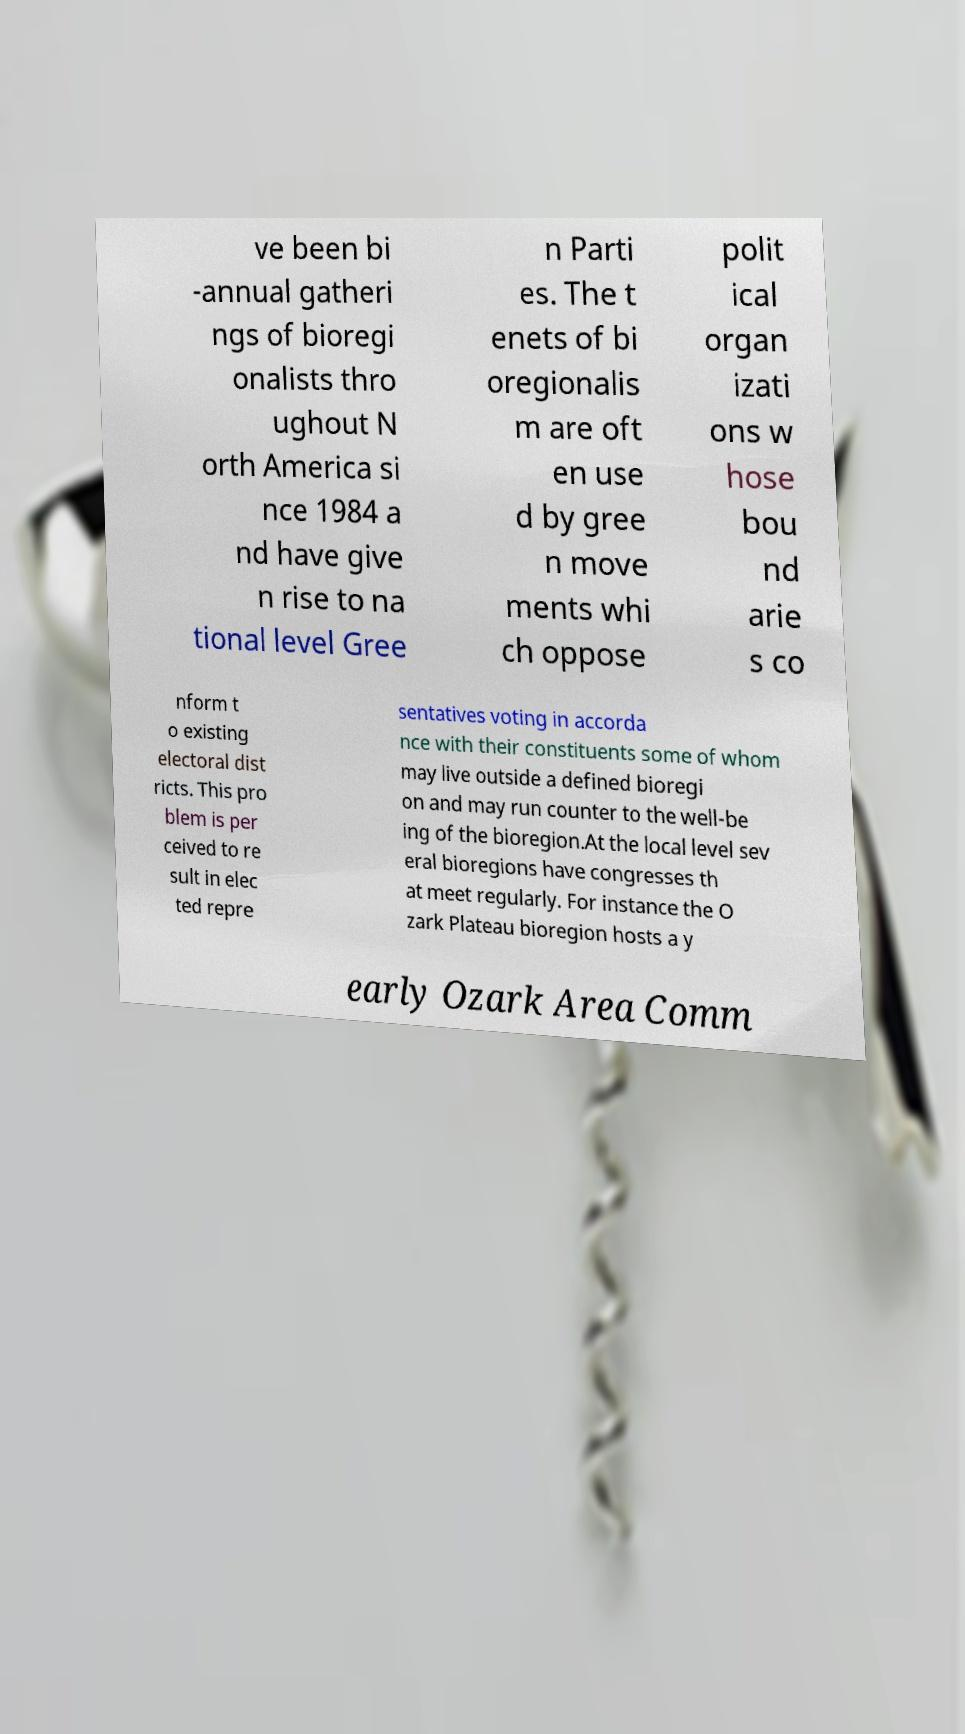Can you read and provide the text displayed in the image?This photo seems to have some interesting text. Can you extract and type it out for me? ve been bi -annual gatheri ngs of bioregi onalists thro ughout N orth America si nce 1984 a nd have give n rise to na tional level Gree n Parti es. The t enets of bi oregionalis m are oft en use d by gree n move ments whi ch oppose polit ical organ izati ons w hose bou nd arie s co nform t o existing electoral dist ricts. This pro blem is per ceived to re sult in elec ted repre sentatives voting in accorda nce with their constituents some of whom may live outside a defined bioregi on and may run counter to the well-be ing of the bioregion.At the local level sev eral bioregions have congresses th at meet regularly. For instance the O zark Plateau bioregion hosts a y early Ozark Area Comm 